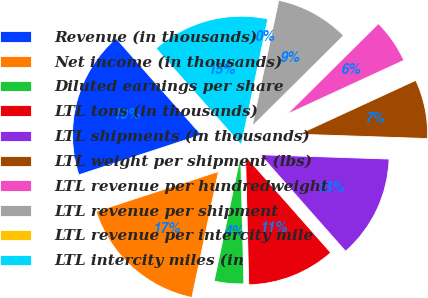<chart> <loc_0><loc_0><loc_500><loc_500><pie_chart><fcel>Revenue (in thousands)<fcel>Net income (in thousands)<fcel>Diluted earnings per share<fcel>LTL tons (in thousands)<fcel>LTL shipments (in thousands)<fcel>LTL weight per shipment (lbs)<fcel>LTL revenue per hundredweight<fcel>LTL revenue per shipment<fcel>LTL revenue per intercity mile<fcel>LTL intercity miles (in<nl><fcel>18.52%<fcel>16.67%<fcel>3.7%<fcel>11.11%<fcel>12.96%<fcel>7.41%<fcel>5.56%<fcel>9.26%<fcel>0.0%<fcel>14.81%<nl></chart> 